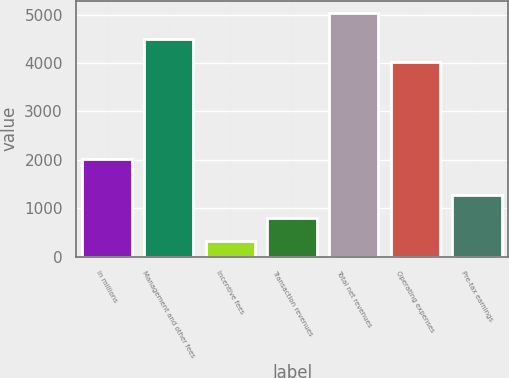Convert chart. <chart><loc_0><loc_0><loc_500><loc_500><bar_chart><fcel>in millions<fcel>Management and other fees<fcel>Incentive fees<fcel>Transaction revenues<fcel>Total net revenues<fcel>Operating expenses<fcel>Pre-tax earnings<nl><fcel>2011<fcel>4491.1<fcel>323<fcel>794.1<fcel>5034<fcel>4020<fcel>1265.2<nl></chart> 